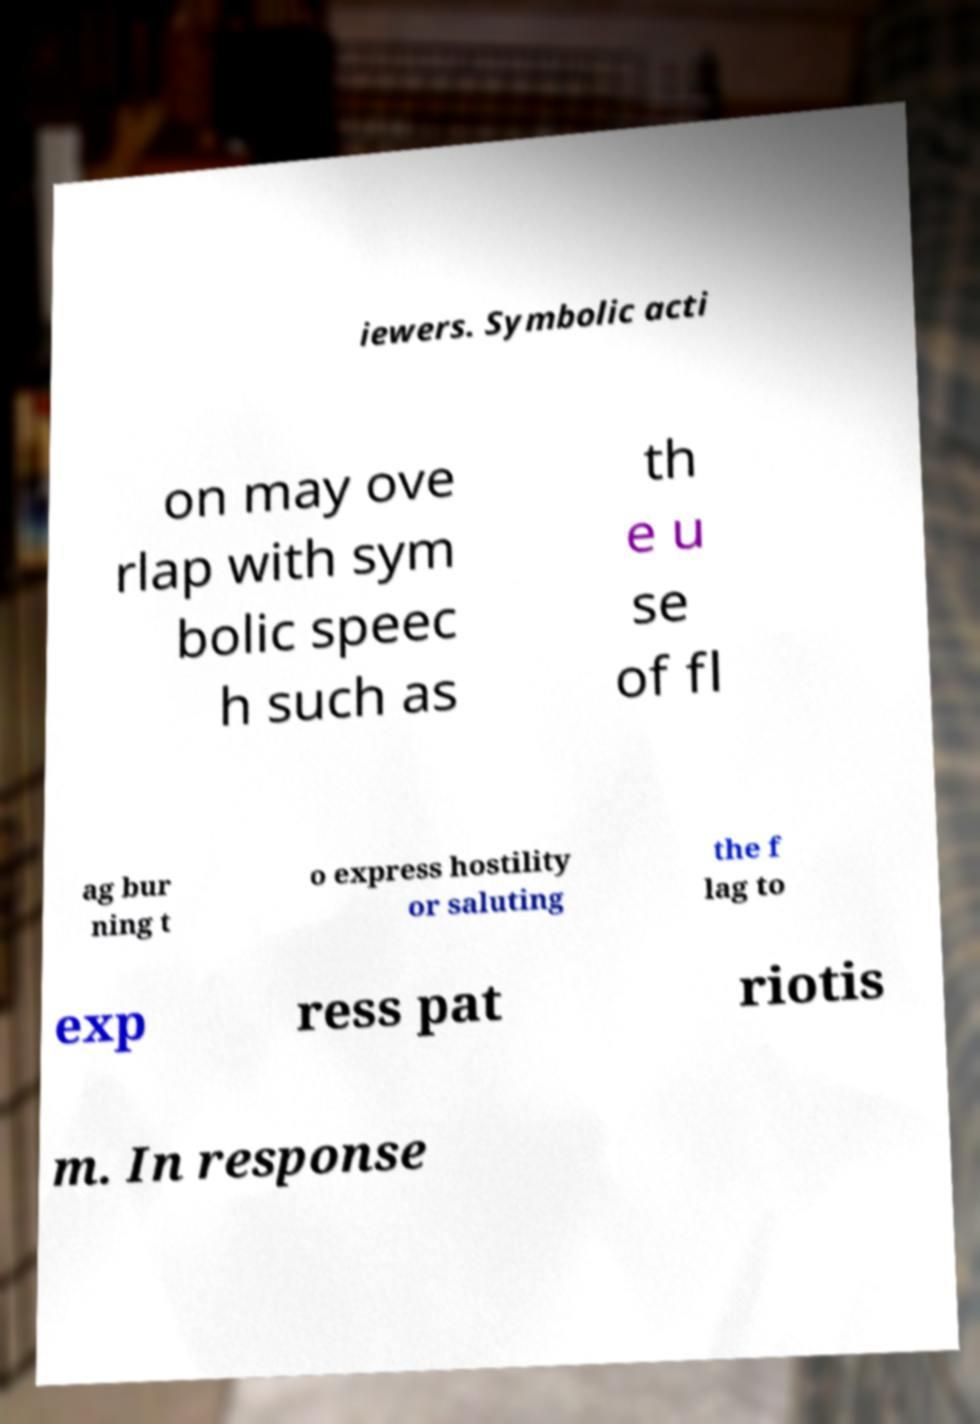I need the written content from this picture converted into text. Can you do that? iewers. Symbolic acti on may ove rlap with sym bolic speec h such as th e u se of fl ag bur ning t o express hostility or saluting the f lag to exp ress pat riotis m. In response 